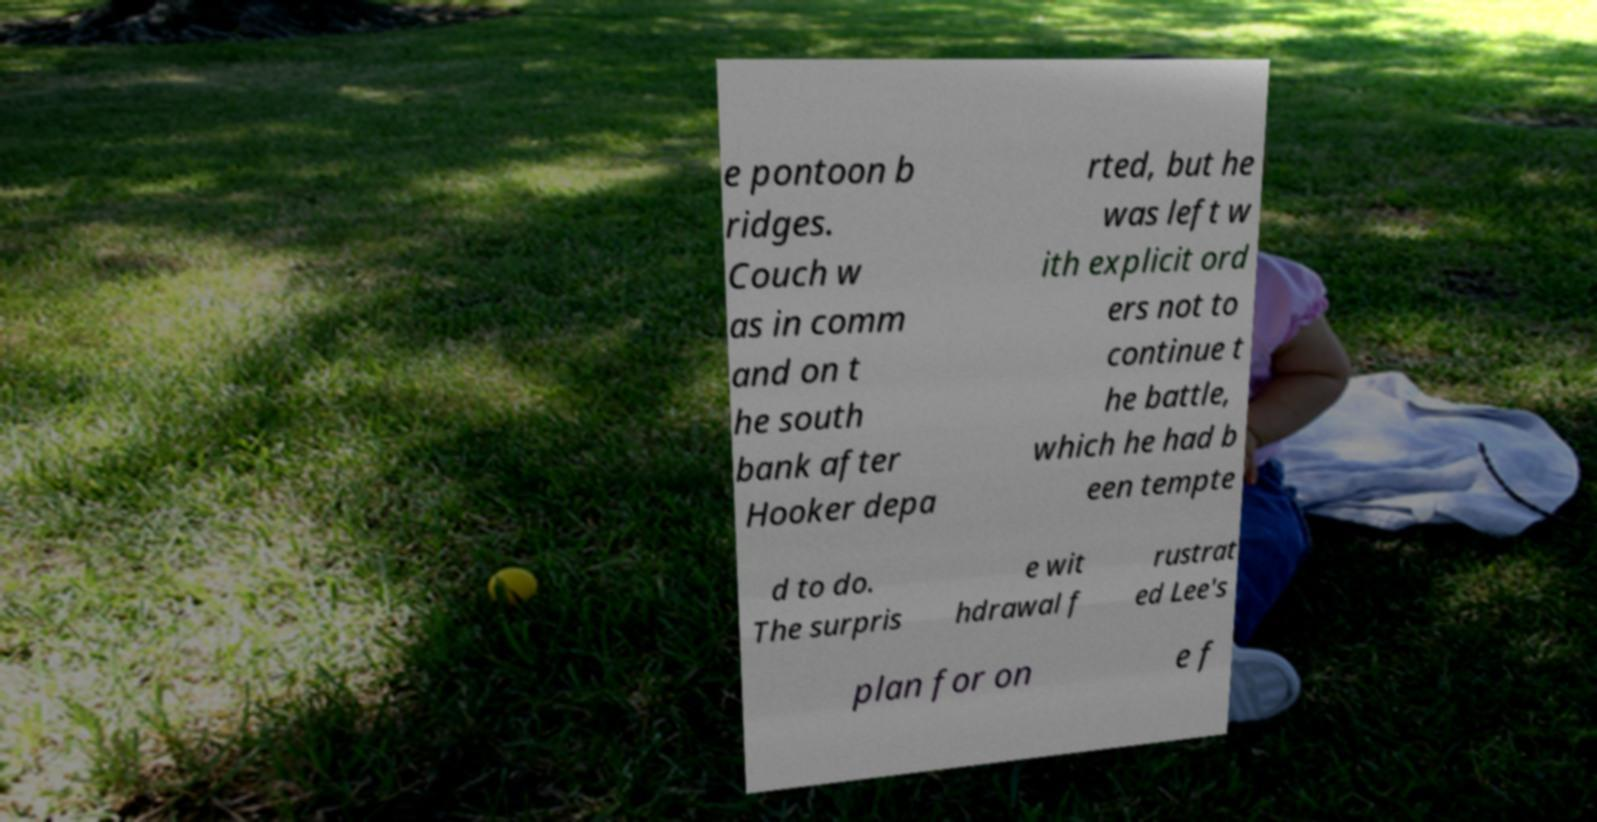Could you extract and type out the text from this image? e pontoon b ridges. Couch w as in comm and on t he south bank after Hooker depa rted, but he was left w ith explicit ord ers not to continue t he battle, which he had b een tempte d to do. The surpris e wit hdrawal f rustrat ed Lee's plan for on e f 